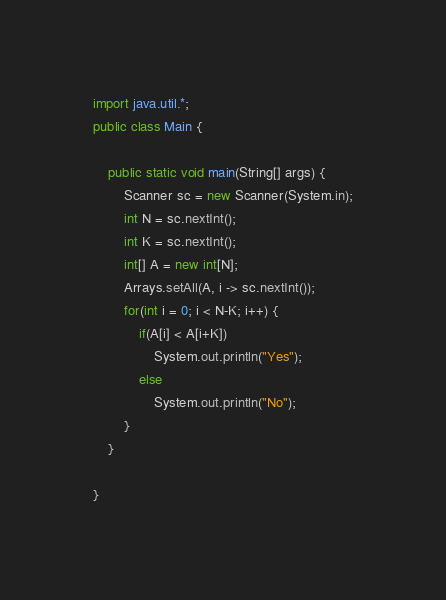Convert code to text. <code><loc_0><loc_0><loc_500><loc_500><_Java_>import java.util.*;
public class Main {

	public static void main(String[] args) {
		Scanner sc = new Scanner(System.in);
		int N = sc.nextInt();
		int K = sc.nextInt();
		int[] A = new int[N];
		Arrays.setAll(A, i -> sc.nextInt());
		for(int i = 0; i < N-K; i++) {
			if(A[i] < A[i+K])
				System.out.println("Yes");
			else
				System.out.println("No");
		}
	}

}
</code> 